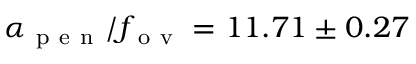Convert formula to latex. <formula><loc_0><loc_0><loc_500><loc_500>\alpha _ { p e n } / f _ { o v } = 1 1 . 7 1 \pm 0 . 2 7</formula> 